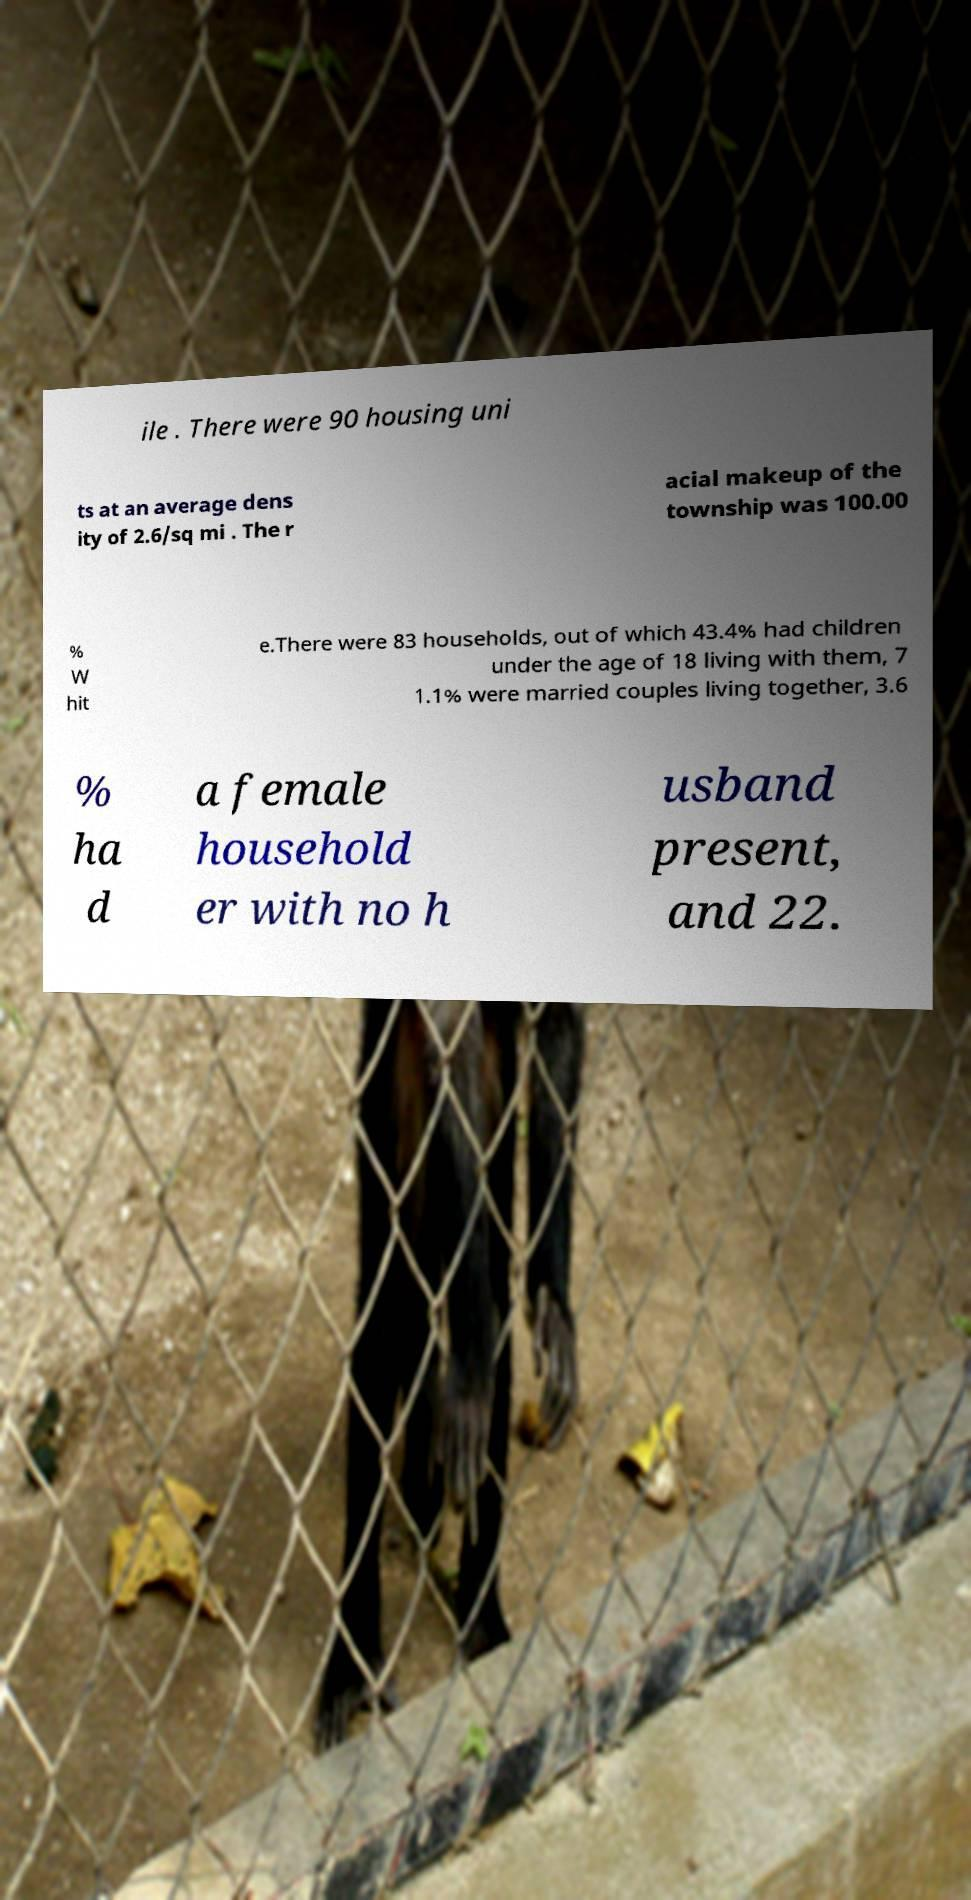There's text embedded in this image that I need extracted. Can you transcribe it verbatim? ile . There were 90 housing uni ts at an average dens ity of 2.6/sq mi . The r acial makeup of the township was 100.00 % W hit e.There were 83 households, out of which 43.4% had children under the age of 18 living with them, 7 1.1% were married couples living together, 3.6 % ha d a female household er with no h usband present, and 22. 